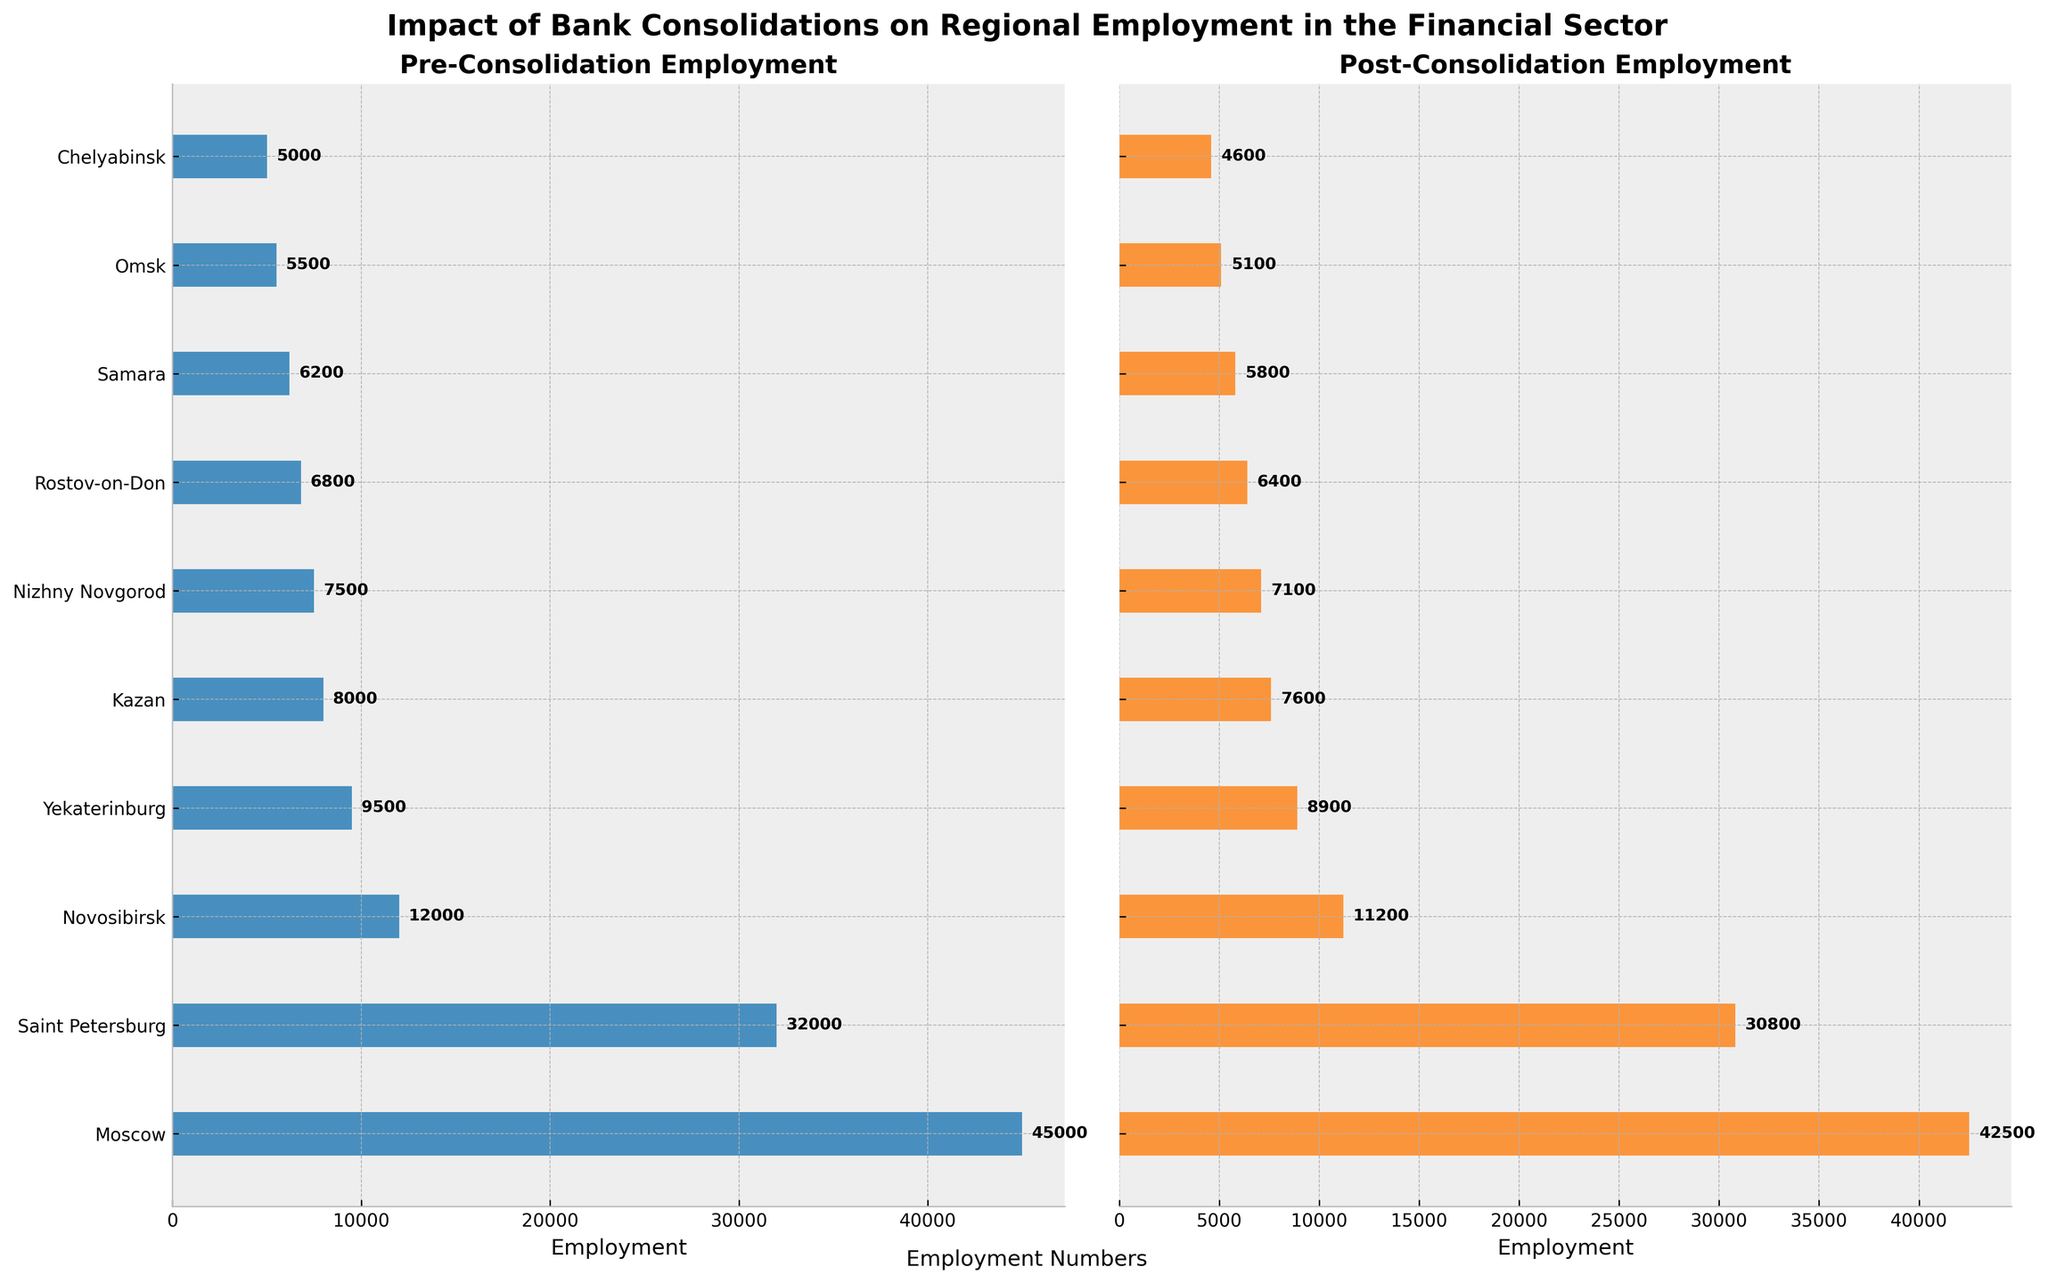What is the title of the figure? The title is displayed at the top of the figure. It reads "Impact of Bank Consolidations on Regional Employment in the Financial Sector".
Answer: Impact of Bank Consolidations on Regional Employment in the Financial Sector How many regions are represented in the figure? Each bar in both subplots represents a region. Counting the bars gives us the total number of regions, which is 10.
Answer: 10 Which region has the highest pre-consolidation employment? In the pre-consolidation subplot, we look for the longest bar. Moscow has the longest bar with an employment value of 45,000.
Answer: Moscow Which region has the smallest drop in employment after consolidation? Calculate the difference for each region: Moscow (2,500), Saint Petersburg (1,200), Novosibirsk (800), Yekaterinburg (600), Kazan (400), Nizhny Novgorod (400), Rostov-on-Don (400), Samara (400), Omsk (400), Chelyabinsk (400). The smallest drop is for Kazan, Nizhny Novgorod, Rostov-on-Don, Samara, Omsk, and Chelyabinsk at 400 each.
Answer: Kazan, Nizhny Novgorod, Rostov-on-Don, Samara, Omsk, Chelyabinsk What is the total employment loss across all regions due to consolidation? Sum the difference in employment for each region: (45000-42500) + (32000-30800) + (12000-11200) + (9500-8900) + (8000-7600) + (7500-7100) + (6800-6400) + (6200-5800) + (5500-5100) + (5000-4600) = 2500 + 1200 + 800 + 600 + 400 + 400 + 400 + 400 + 400 + 400 = 8500.
Answer: 8,500 Which region had the least employment both pre- and post-consolidation? In both subplots, the region with the shortest bar and thus the least employment is Chelyabinsk with pre-consolidation employment of 5,000 and post-consolidation employment of 4,600.
Answer: Chelyabinsk How does the pre-consolidation employment in Saint Petersburg compare to that in Novosibirsk? We look at the lengths of the bars in the pre-consolidation subplot. Saint Petersburg (32,000) has higher employment than Novosibirsk (12,000).
Answer: Saint Petersburg is higher than Novosibirsk What is the average post-consolidation employment across all regions? Sum the post-consolidation employment values and divide by the number of regions: (42500 + 30800 + 11200 + 8900 + 7600 + 7100 + 6400 + 5800 + 5100 + 4600)/10 = 125,900/10 = 12,590.
Answer: 12,590 Which region experienced the largest percentage decrease in employment due to consolidation? Calculate the percentage decrease for each region: Moscow ((45000-42500)/45000)≈5.56%, Saint Petersburg ((32000-30800)/32000)≈3.75%, Novosibirsk ((12000-11200)/12000)≈6.67%, Yekaterinburg ((9500-8900)/9500)≈6.32%, Kazan ((8000-7600)/8000)≈5%, Nizhny Novgorod ((7500-7100)/7500)≈5.33%, Rostov-on-Don ((6800-6400)/6800)≈5.88%, Samara ((6200-5800)/6200)≈6.45%, Omsk ((5500-5100)/5500)≈7.27%, Chelyabinsk ((5000-4600)/5000)≈8%. The largest percentage decrease is in Chelyabinsk at 8%.
Answer: Chelyabinsk 